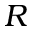<formula> <loc_0><loc_0><loc_500><loc_500>R</formula> 